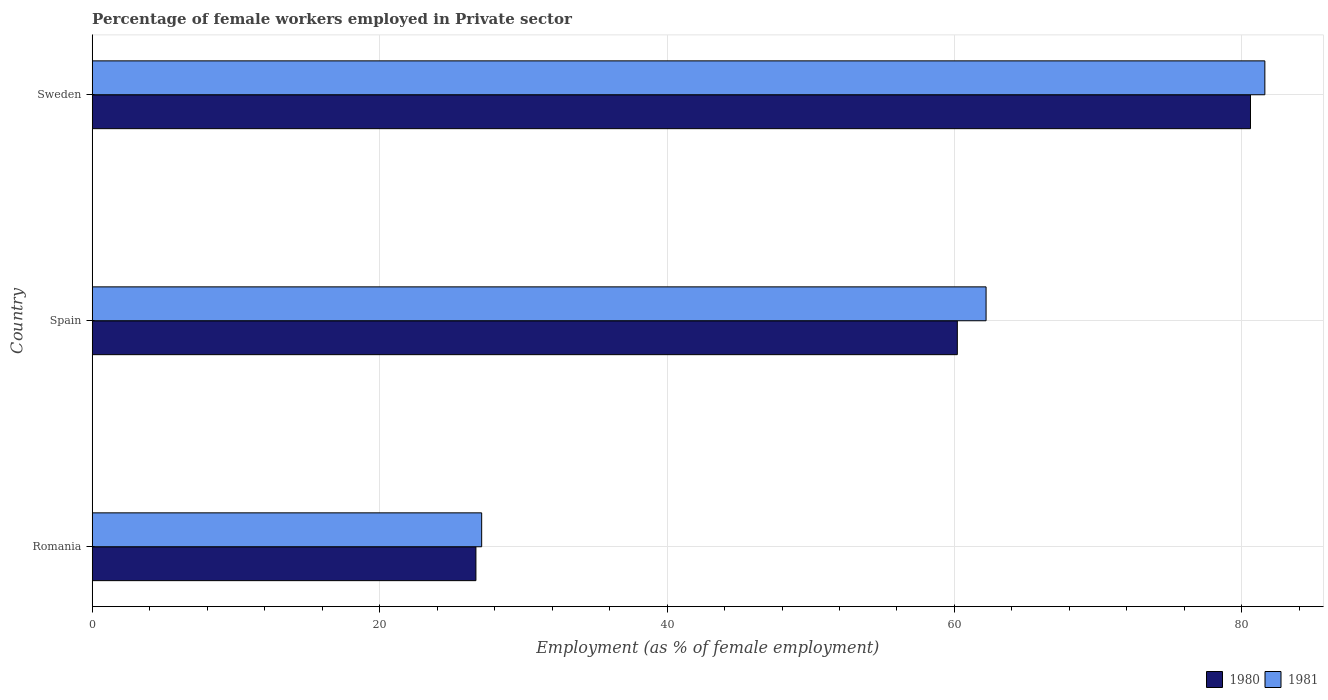How many bars are there on the 2nd tick from the top?
Offer a terse response. 2. How many bars are there on the 1st tick from the bottom?
Your response must be concise. 2. What is the label of the 3rd group of bars from the top?
Ensure brevity in your answer.  Romania. What is the percentage of females employed in Private sector in 1981 in Sweden?
Ensure brevity in your answer.  81.6. Across all countries, what is the maximum percentage of females employed in Private sector in 1980?
Give a very brief answer. 80.6. Across all countries, what is the minimum percentage of females employed in Private sector in 1980?
Provide a succinct answer. 26.7. In which country was the percentage of females employed in Private sector in 1980 maximum?
Offer a terse response. Sweden. In which country was the percentage of females employed in Private sector in 1981 minimum?
Your answer should be very brief. Romania. What is the total percentage of females employed in Private sector in 1980 in the graph?
Give a very brief answer. 167.5. What is the difference between the percentage of females employed in Private sector in 1981 in Romania and that in Sweden?
Offer a terse response. -54.5. What is the difference between the percentage of females employed in Private sector in 1981 in Spain and the percentage of females employed in Private sector in 1980 in Romania?
Ensure brevity in your answer.  35.5. What is the average percentage of females employed in Private sector in 1980 per country?
Make the answer very short. 55.83. What is the difference between the percentage of females employed in Private sector in 1981 and percentage of females employed in Private sector in 1980 in Romania?
Provide a succinct answer. 0.4. What is the ratio of the percentage of females employed in Private sector in 1980 in Spain to that in Sweden?
Provide a short and direct response. 0.75. Is the difference between the percentage of females employed in Private sector in 1981 in Spain and Sweden greater than the difference between the percentage of females employed in Private sector in 1980 in Spain and Sweden?
Ensure brevity in your answer.  Yes. What is the difference between the highest and the second highest percentage of females employed in Private sector in 1980?
Your response must be concise. 20.4. What is the difference between the highest and the lowest percentage of females employed in Private sector in 1981?
Offer a terse response. 54.5. In how many countries, is the percentage of females employed in Private sector in 1981 greater than the average percentage of females employed in Private sector in 1981 taken over all countries?
Keep it short and to the point. 2. What does the 2nd bar from the bottom in Romania represents?
Provide a succinct answer. 1981. Are all the bars in the graph horizontal?
Provide a succinct answer. Yes. How many countries are there in the graph?
Give a very brief answer. 3. Are the values on the major ticks of X-axis written in scientific E-notation?
Provide a succinct answer. No. Does the graph contain grids?
Keep it short and to the point. Yes. Where does the legend appear in the graph?
Ensure brevity in your answer.  Bottom right. What is the title of the graph?
Ensure brevity in your answer.  Percentage of female workers employed in Private sector. Does "1995" appear as one of the legend labels in the graph?
Ensure brevity in your answer.  No. What is the label or title of the X-axis?
Ensure brevity in your answer.  Employment (as % of female employment). What is the label or title of the Y-axis?
Give a very brief answer. Country. What is the Employment (as % of female employment) of 1980 in Romania?
Keep it short and to the point. 26.7. What is the Employment (as % of female employment) of 1981 in Romania?
Provide a short and direct response. 27.1. What is the Employment (as % of female employment) in 1980 in Spain?
Offer a very short reply. 60.2. What is the Employment (as % of female employment) of 1981 in Spain?
Offer a terse response. 62.2. What is the Employment (as % of female employment) in 1980 in Sweden?
Offer a terse response. 80.6. What is the Employment (as % of female employment) in 1981 in Sweden?
Offer a very short reply. 81.6. Across all countries, what is the maximum Employment (as % of female employment) in 1980?
Keep it short and to the point. 80.6. Across all countries, what is the maximum Employment (as % of female employment) in 1981?
Ensure brevity in your answer.  81.6. Across all countries, what is the minimum Employment (as % of female employment) in 1980?
Keep it short and to the point. 26.7. Across all countries, what is the minimum Employment (as % of female employment) in 1981?
Offer a terse response. 27.1. What is the total Employment (as % of female employment) in 1980 in the graph?
Give a very brief answer. 167.5. What is the total Employment (as % of female employment) in 1981 in the graph?
Ensure brevity in your answer.  170.9. What is the difference between the Employment (as % of female employment) in 1980 in Romania and that in Spain?
Provide a short and direct response. -33.5. What is the difference between the Employment (as % of female employment) of 1981 in Romania and that in Spain?
Your answer should be very brief. -35.1. What is the difference between the Employment (as % of female employment) in 1980 in Romania and that in Sweden?
Offer a very short reply. -53.9. What is the difference between the Employment (as % of female employment) in 1981 in Romania and that in Sweden?
Provide a short and direct response. -54.5. What is the difference between the Employment (as % of female employment) in 1980 in Spain and that in Sweden?
Provide a short and direct response. -20.4. What is the difference between the Employment (as % of female employment) of 1981 in Spain and that in Sweden?
Offer a terse response. -19.4. What is the difference between the Employment (as % of female employment) of 1980 in Romania and the Employment (as % of female employment) of 1981 in Spain?
Provide a short and direct response. -35.5. What is the difference between the Employment (as % of female employment) of 1980 in Romania and the Employment (as % of female employment) of 1981 in Sweden?
Provide a succinct answer. -54.9. What is the difference between the Employment (as % of female employment) in 1980 in Spain and the Employment (as % of female employment) in 1981 in Sweden?
Keep it short and to the point. -21.4. What is the average Employment (as % of female employment) of 1980 per country?
Keep it short and to the point. 55.83. What is the average Employment (as % of female employment) of 1981 per country?
Ensure brevity in your answer.  56.97. What is the difference between the Employment (as % of female employment) in 1980 and Employment (as % of female employment) in 1981 in Romania?
Give a very brief answer. -0.4. What is the difference between the Employment (as % of female employment) in 1980 and Employment (as % of female employment) in 1981 in Spain?
Your answer should be compact. -2. What is the ratio of the Employment (as % of female employment) of 1980 in Romania to that in Spain?
Keep it short and to the point. 0.44. What is the ratio of the Employment (as % of female employment) of 1981 in Romania to that in Spain?
Your answer should be very brief. 0.44. What is the ratio of the Employment (as % of female employment) in 1980 in Romania to that in Sweden?
Provide a short and direct response. 0.33. What is the ratio of the Employment (as % of female employment) of 1981 in Romania to that in Sweden?
Offer a very short reply. 0.33. What is the ratio of the Employment (as % of female employment) of 1980 in Spain to that in Sweden?
Provide a short and direct response. 0.75. What is the ratio of the Employment (as % of female employment) in 1981 in Spain to that in Sweden?
Give a very brief answer. 0.76. What is the difference between the highest and the second highest Employment (as % of female employment) of 1980?
Provide a short and direct response. 20.4. What is the difference between the highest and the second highest Employment (as % of female employment) in 1981?
Your response must be concise. 19.4. What is the difference between the highest and the lowest Employment (as % of female employment) of 1980?
Ensure brevity in your answer.  53.9. What is the difference between the highest and the lowest Employment (as % of female employment) of 1981?
Provide a succinct answer. 54.5. 